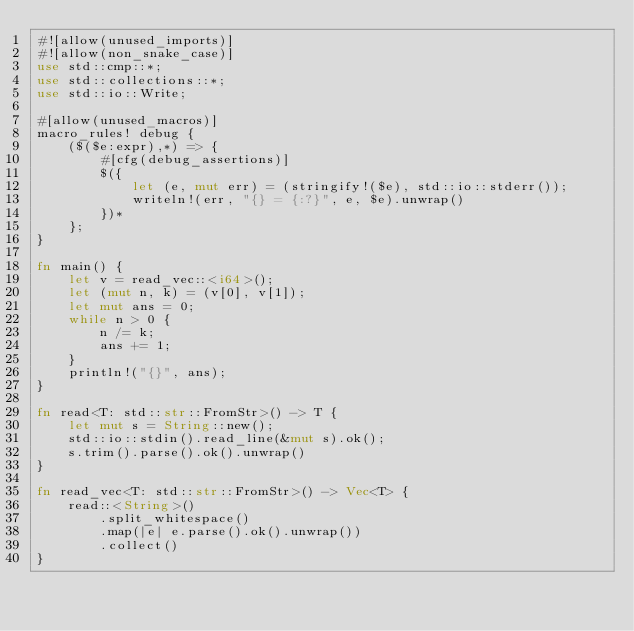Convert code to text. <code><loc_0><loc_0><loc_500><loc_500><_Rust_>#![allow(unused_imports)]
#![allow(non_snake_case)]
use std::cmp::*;
use std::collections::*;
use std::io::Write;

#[allow(unused_macros)]
macro_rules! debug {
    ($($e:expr),*) => {
        #[cfg(debug_assertions)]
        $({
            let (e, mut err) = (stringify!($e), std::io::stderr());
            writeln!(err, "{} = {:?}", e, $e).unwrap()
        })*
    };
}

fn main() {
    let v = read_vec::<i64>();
    let (mut n, k) = (v[0], v[1]);
    let mut ans = 0;
    while n > 0 {
        n /= k;
        ans += 1;
    }
    println!("{}", ans);
}

fn read<T: std::str::FromStr>() -> T {
    let mut s = String::new();
    std::io::stdin().read_line(&mut s).ok();
    s.trim().parse().ok().unwrap()
}

fn read_vec<T: std::str::FromStr>() -> Vec<T> {
    read::<String>()
        .split_whitespace()
        .map(|e| e.parse().ok().unwrap())
        .collect()
}
</code> 